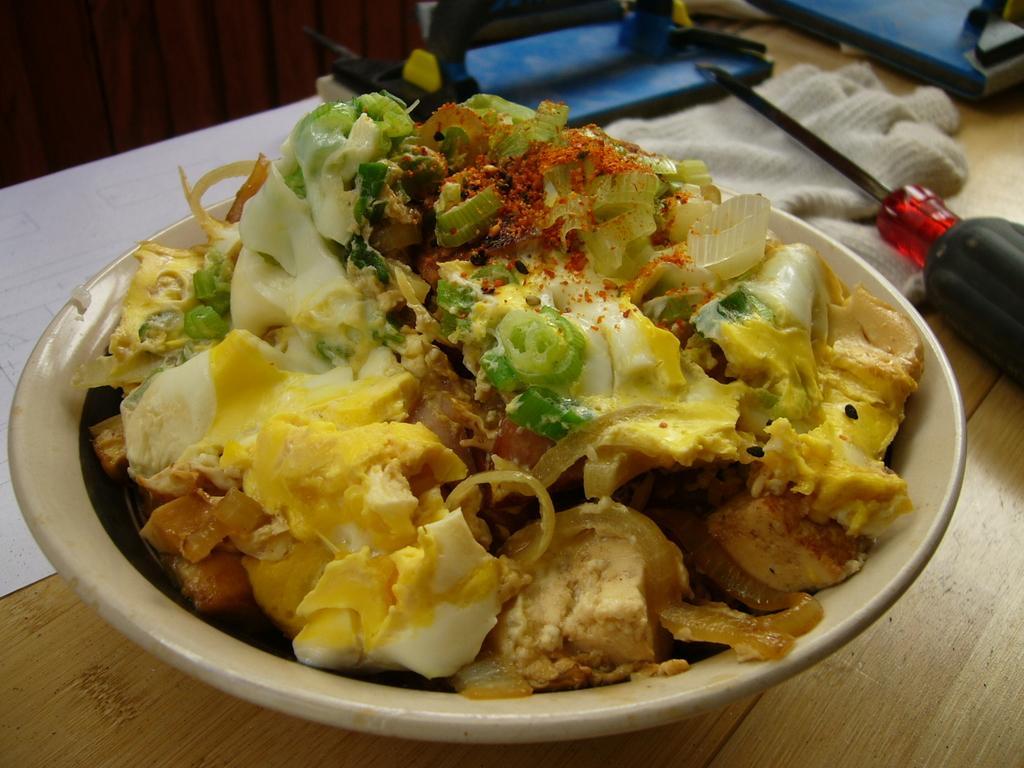Can you describe this image briefly? The picture consists of a table, on the table there are paper, cloth, screwdriver, bowl, food item and some other objects. 